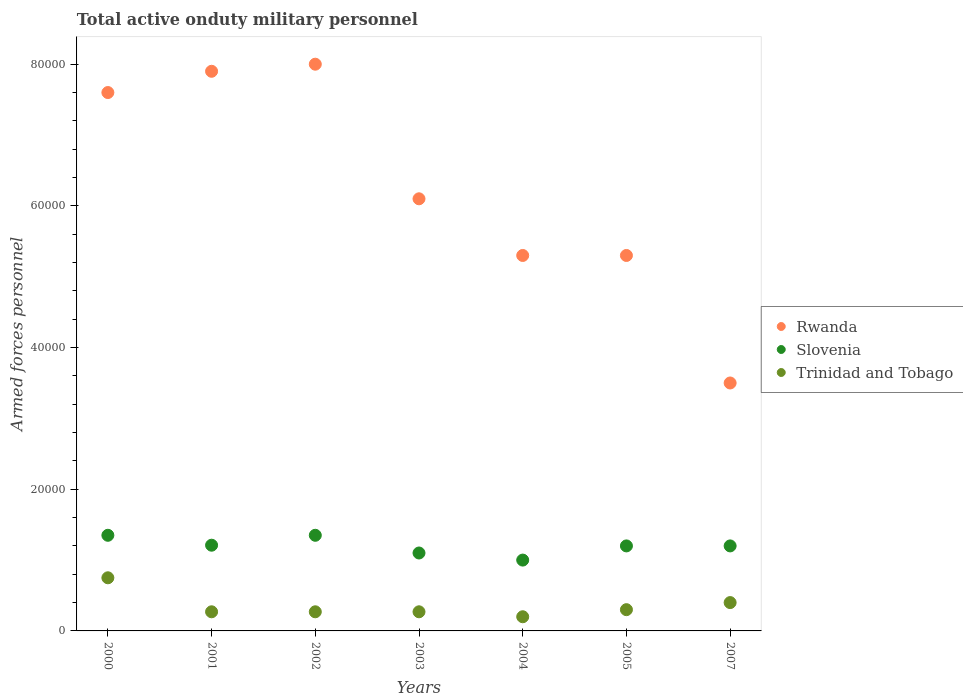How many different coloured dotlines are there?
Offer a very short reply. 3. What is the number of armed forces personnel in Trinidad and Tobago in 2003?
Offer a terse response. 2700. Across all years, what is the maximum number of armed forces personnel in Trinidad and Tobago?
Your answer should be compact. 7500. What is the total number of armed forces personnel in Trinidad and Tobago in the graph?
Make the answer very short. 2.46e+04. What is the difference between the number of armed forces personnel in Trinidad and Tobago in 2005 and that in 2007?
Your answer should be very brief. -1000. What is the difference between the number of armed forces personnel in Rwanda in 2002 and the number of armed forces personnel in Trinidad and Tobago in 2000?
Your answer should be compact. 7.25e+04. What is the average number of armed forces personnel in Trinidad and Tobago per year?
Provide a short and direct response. 3514.29. In the year 2004, what is the difference between the number of armed forces personnel in Slovenia and number of armed forces personnel in Rwanda?
Your answer should be compact. -4.30e+04. What is the ratio of the number of armed forces personnel in Trinidad and Tobago in 2004 to that in 2007?
Your answer should be compact. 0.5. Is the number of armed forces personnel in Slovenia in 2001 less than that in 2004?
Your answer should be compact. No. Is the difference between the number of armed forces personnel in Slovenia in 2002 and 2007 greater than the difference between the number of armed forces personnel in Rwanda in 2002 and 2007?
Give a very brief answer. No. What is the difference between the highest and the second highest number of armed forces personnel in Trinidad and Tobago?
Keep it short and to the point. 3500. What is the difference between the highest and the lowest number of armed forces personnel in Trinidad and Tobago?
Your response must be concise. 5500. Is the sum of the number of armed forces personnel in Trinidad and Tobago in 2003 and 2007 greater than the maximum number of armed forces personnel in Rwanda across all years?
Keep it short and to the point. No. Does the number of armed forces personnel in Trinidad and Tobago monotonically increase over the years?
Ensure brevity in your answer.  No. How many dotlines are there?
Keep it short and to the point. 3. How many years are there in the graph?
Your answer should be compact. 7. Are the values on the major ticks of Y-axis written in scientific E-notation?
Your answer should be very brief. No. Does the graph contain any zero values?
Offer a very short reply. No. What is the title of the graph?
Offer a very short reply. Total active onduty military personnel. What is the label or title of the X-axis?
Your answer should be compact. Years. What is the label or title of the Y-axis?
Ensure brevity in your answer.  Armed forces personnel. What is the Armed forces personnel of Rwanda in 2000?
Offer a terse response. 7.60e+04. What is the Armed forces personnel in Slovenia in 2000?
Your answer should be compact. 1.35e+04. What is the Armed forces personnel of Trinidad and Tobago in 2000?
Provide a short and direct response. 7500. What is the Armed forces personnel of Rwanda in 2001?
Keep it short and to the point. 7.90e+04. What is the Armed forces personnel in Slovenia in 2001?
Offer a terse response. 1.21e+04. What is the Armed forces personnel of Trinidad and Tobago in 2001?
Offer a terse response. 2700. What is the Armed forces personnel of Slovenia in 2002?
Give a very brief answer. 1.35e+04. What is the Armed forces personnel in Trinidad and Tobago in 2002?
Give a very brief answer. 2700. What is the Armed forces personnel in Rwanda in 2003?
Your answer should be very brief. 6.10e+04. What is the Armed forces personnel of Slovenia in 2003?
Provide a short and direct response. 1.10e+04. What is the Armed forces personnel in Trinidad and Tobago in 2003?
Your answer should be very brief. 2700. What is the Armed forces personnel of Rwanda in 2004?
Your answer should be very brief. 5.30e+04. What is the Armed forces personnel in Slovenia in 2004?
Offer a very short reply. 10000. What is the Armed forces personnel of Rwanda in 2005?
Give a very brief answer. 5.30e+04. What is the Armed forces personnel in Slovenia in 2005?
Offer a very short reply. 1.20e+04. What is the Armed forces personnel in Trinidad and Tobago in 2005?
Keep it short and to the point. 3000. What is the Armed forces personnel of Rwanda in 2007?
Offer a very short reply. 3.50e+04. What is the Armed forces personnel in Slovenia in 2007?
Ensure brevity in your answer.  1.20e+04. What is the Armed forces personnel in Trinidad and Tobago in 2007?
Ensure brevity in your answer.  4000. Across all years, what is the maximum Armed forces personnel of Slovenia?
Make the answer very short. 1.35e+04. Across all years, what is the maximum Armed forces personnel of Trinidad and Tobago?
Offer a terse response. 7500. Across all years, what is the minimum Armed forces personnel in Rwanda?
Provide a short and direct response. 3.50e+04. Across all years, what is the minimum Armed forces personnel of Trinidad and Tobago?
Your response must be concise. 2000. What is the total Armed forces personnel in Rwanda in the graph?
Provide a succinct answer. 4.37e+05. What is the total Armed forces personnel in Slovenia in the graph?
Provide a succinct answer. 8.41e+04. What is the total Armed forces personnel in Trinidad and Tobago in the graph?
Make the answer very short. 2.46e+04. What is the difference between the Armed forces personnel of Rwanda in 2000 and that in 2001?
Your answer should be very brief. -3000. What is the difference between the Armed forces personnel in Slovenia in 2000 and that in 2001?
Offer a very short reply. 1400. What is the difference between the Armed forces personnel in Trinidad and Tobago in 2000 and that in 2001?
Ensure brevity in your answer.  4800. What is the difference between the Armed forces personnel of Rwanda in 2000 and that in 2002?
Give a very brief answer. -4000. What is the difference between the Armed forces personnel of Trinidad and Tobago in 2000 and that in 2002?
Give a very brief answer. 4800. What is the difference between the Armed forces personnel of Rwanda in 2000 and that in 2003?
Offer a very short reply. 1.50e+04. What is the difference between the Armed forces personnel in Slovenia in 2000 and that in 2003?
Give a very brief answer. 2500. What is the difference between the Armed forces personnel in Trinidad and Tobago in 2000 and that in 2003?
Your response must be concise. 4800. What is the difference between the Armed forces personnel in Rwanda in 2000 and that in 2004?
Your response must be concise. 2.30e+04. What is the difference between the Armed forces personnel of Slovenia in 2000 and that in 2004?
Provide a succinct answer. 3500. What is the difference between the Armed forces personnel of Trinidad and Tobago in 2000 and that in 2004?
Keep it short and to the point. 5500. What is the difference between the Armed forces personnel of Rwanda in 2000 and that in 2005?
Your response must be concise. 2.30e+04. What is the difference between the Armed forces personnel of Slovenia in 2000 and that in 2005?
Ensure brevity in your answer.  1500. What is the difference between the Armed forces personnel in Trinidad and Tobago in 2000 and that in 2005?
Ensure brevity in your answer.  4500. What is the difference between the Armed forces personnel of Rwanda in 2000 and that in 2007?
Make the answer very short. 4.10e+04. What is the difference between the Armed forces personnel in Slovenia in 2000 and that in 2007?
Provide a succinct answer. 1500. What is the difference between the Armed forces personnel in Trinidad and Tobago in 2000 and that in 2007?
Make the answer very short. 3500. What is the difference between the Armed forces personnel of Rwanda in 2001 and that in 2002?
Offer a very short reply. -1000. What is the difference between the Armed forces personnel in Slovenia in 2001 and that in 2002?
Offer a terse response. -1400. What is the difference between the Armed forces personnel in Rwanda in 2001 and that in 2003?
Ensure brevity in your answer.  1.80e+04. What is the difference between the Armed forces personnel in Slovenia in 2001 and that in 2003?
Give a very brief answer. 1100. What is the difference between the Armed forces personnel of Rwanda in 2001 and that in 2004?
Offer a terse response. 2.60e+04. What is the difference between the Armed forces personnel in Slovenia in 2001 and that in 2004?
Ensure brevity in your answer.  2100. What is the difference between the Armed forces personnel of Trinidad and Tobago in 2001 and that in 2004?
Offer a very short reply. 700. What is the difference between the Armed forces personnel in Rwanda in 2001 and that in 2005?
Provide a short and direct response. 2.60e+04. What is the difference between the Armed forces personnel of Slovenia in 2001 and that in 2005?
Provide a succinct answer. 100. What is the difference between the Armed forces personnel in Trinidad and Tobago in 2001 and that in 2005?
Keep it short and to the point. -300. What is the difference between the Armed forces personnel of Rwanda in 2001 and that in 2007?
Offer a very short reply. 4.40e+04. What is the difference between the Armed forces personnel of Slovenia in 2001 and that in 2007?
Ensure brevity in your answer.  100. What is the difference between the Armed forces personnel of Trinidad and Tobago in 2001 and that in 2007?
Offer a very short reply. -1300. What is the difference between the Armed forces personnel of Rwanda in 2002 and that in 2003?
Keep it short and to the point. 1.90e+04. What is the difference between the Armed forces personnel of Slovenia in 2002 and that in 2003?
Your answer should be compact. 2500. What is the difference between the Armed forces personnel of Trinidad and Tobago in 2002 and that in 2003?
Give a very brief answer. 0. What is the difference between the Armed forces personnel of Rwanda in 2002 and that in 2004?
Offer a terse response. 2.70e+04. What is the difference between the Armed forces personnel in Slovenia in 2002 and that in 2004?
Give a very brief answer. 3500. What is the difference between the Armed forces personnel in Trinidad and Tobago in 2002 and that in 2004?
Make the answer very short. 700. What is the difference between the Armed forces personnel in Rwanda in 2002 and that in 2005?
Your answer should be compact. 2.70e+04. What is the difference between the Armed forces personnel of Slovenia in 2002 and that in 2005?
Provide a succinct answer. 1500. What is the difference between the Armed forces personnel of Trinidad and Tobago in 2002 and that in 2005?
Make the answer very short. -300. What is the difference between the Armed forces personnel in Rwanda in 2002 and that in 2007?
Your answer should be compact. 4.50e+04. What is the difference between the Armed forces personnel of Slovenia in 2002 and that in 2007?
Offer a very short reply. 1500. What is the difference between the Armed forces personnel in Trinidad and Tobago in 2002 and that in 2007?
Your answer should be very brief. -1300. What is the difference between the Armed forces personnel in Rwanda in 2003 and that in 2004?
Offer a terse response. 8000. What is the difference between the Armed forces personnel of Slovenia in 2003 and that in 2004?
Your answer should be very brief. 1000. What is the difference between the Armed forces personnel of Trinidad and Tobago in 2003 and that in 2004?
Give a very brief answer. 700. What is the difference between the Armed forces personnel in Rwanda in 2003 and that in 2005?
Ensure brevity in your answer.  8000. What is the difference between the Armed forces personnel in Slovenia in 2003 and that in 2005?
Your answer should be very brief. -1000. What is the difference between the Armed forces personnel in Trinidad and Tobago in 2003 and that in 2005?
Offer a very short reply. -300. What is the difference between the Armed forces personnel of Rwanda in 2003 and that in 2007?
Offer a very short reply. 2.60e+04. What is the difference between the Armed forces personnel of Slovenia in 2003 and that in 2007?
Your response must be concise. -1000. What is the difference between the Armed forces personnel of Trinidad and Tobago in 2003 and that in 2007?
Your response must be concise. -1300. What is the difference between the Armed forces personnel of Slovenia in 2004 and that in 2005?
Provide a succinct answer. -2000. What is the difference between the Armed forces personnel in Trinidad and Tobago in 2004 and that in 2005?
Your answer should be very brief. -1000. What is the difference between the Armed forces personnel of Rwanda in 2004 and that in 2007?
Give a very brief answer. 1.80e+04. What is the difference between the Armed forces personnel of Slovenia in 2004 and that in 2007?
Provide a short and direct response. -2000. What is the difference between the Armed forces personnel in Trinidad and Tobago in 2004 and that in 2007?
Your answer should be compact. -2000. What is the difference between the Armed forces personnel of Rwanda in 2005 and that in 2007?
Your answer should be compact. 1.80e+04. What is the difference between the Armed forces personnel in Slovenia in 2005 and that in 2007?
Your answer should be compact. 0. What is the difference between the Armed forces personnel of Trinidad and Tobago in 2005 and that in 2007?
Your response must be concise. -1000. What is the difference between the Armed forces personnel of Rwanda in 2000 and the Armed forces personnel of Slovenia in 2001?
Offer a very short reply. 6.39e+04. What is the difference between the Armed forces personnel in Rwanda in 2000 and the Armed forces personnel in Trinidad and Tobago in 2001?
Your response must be concise. 7.33e+04. What is the difference between the Armed forces personnel of Slovenia in 2000 and the Armed forces personnel of Trinidad and Tobago in 2001?
Your answer should be very brief. 1.08e+04. What is the difference between the Armed forces personnel in Rwanda in 2000 and the Armed forces personnel in Slovenia in 2002?
Your answer should be very brief. 6.25e+04. What is the difference between the Armed forces personnel of Rwanda in 2000 and the Armed forces personnel of Trinidad and Tobago in 2002?
Keep it short and to the point. 7.33e+04. What is the difference between the Armed forces personnel of Slovenia in 2000 and the Armed forces personnel of Trinidad and Tobago in 2002?
Provide a short and direct response. 1.08e+04. What is the difference between the Armed forces personnel in Rwanda in 2000 and the Armed forces personnel in Slovenia in 2003?
Keep it short and to the point. 6.50e+04. What is the difference between the Armed forces personnel in Rwanda in 2000 and the Armed forces personnel in Trinidad and Tobago in 2003?
Your answer should be very brief. 7.33e+04. What is the difference between the Armed forces personnel of Slovenia in 2000 and the Armed forces personnel of Trinidad and Tobago in 2003?
Offer a very short reply. 1.08e+04. What is the difference between the Armed forces personnel in Rwanda in 2000 and the Armed forces personnel in Slovenia in 2004?
Provide a short and direct response. 6.60e+04. What is the difference between the Armed forces personnel in Rwanda in 2000 and the Armed forces personnel in Trinidad and Tobago in 2004?
Give a very brief answer. 7.40e+04. What is the difference between the Armed forces personnel in Slovenia in 2000 and the Armed forces personnel in Trinidad and Tobago in 2004?
Offer a very short reply. 1.15e+04. What is the difference between the Armed forces personnel of Rwanda in 2000 and the Armed forces personnel of Slovenia in 2005?
Give a very brief answer. 6.40e+04. What is the difference between the Armed forces personnel in Rwanda in 2000 and the Armed forces personnel in Trinidad and Tobago in 2005?
Offer a very short reply. 7.30e+04. What is the difference between the Armed forces personnel in Slovenia in 2000 and the Armed forces personnel in Trinidad and Tobago in 2005?
Your answer should be very brief. 1.05e+04. What is the difference between the Armed forces personnel in Rwanda in 2000 and the Armed forces personnel in Slovenia in 2007?
Make the answer very short. 6.40e+04. What is the difference between the Armed forces personnel in Rwanda in 2000 and the Armed forces personnel in Trinidad and Tobago in 2007?
Make the answer very short. 7.20e+04. What is the difference between the Armed forces personnel in Slovenia in 2000 and the Armed forces personnel in Trinidad and Tobago in 2007?
Give a very brief answer. 9500. What is the difference between the Armed forces personnel of Rwanda in 2001 and the Armed forces personnel of Slovenia in 2002?
Provide a succinct answer. 6.55e+04. What is the difference between the Armed forces personnel in Rwanda in 2001 and the Armed forces personnel in Trinidad and Tobago in 2002?
Make the answer very short. 7.63e+04. What is the difference between the Armed forces personnel in Slovenia in 2001 and the Armed forces personnel in Trinidad and Tobago in 2002?
Offer a very short reply. 9400. What is the difference between the Armed forces personnel of Rwanda in 2001 and the Armed forces personnel of Slovenia in 2003?
Offer a very short reply. 6.80e+04. What is the difference between the Armed forces personnel of Rwanda in 2001 and the Armed forces personnel of Trinidad and Tobago in 2003?
Offer a very short reply. 7.63e+04. What is the difference between the Armed forces personnel in Slovenia in 2001 and the Armed forces personnel in Trinidad and Tobago in 2003?
Offer a very short reply. 9400. What is the difference between the Armed forces personnel of Rwanda in 2001 and the Armed forces personnel of Slovenia in 2004?
Give a very brief answer. 6.90e+04. What is the difference between the Armed forces personnel in Rwanda in 2001 and the Armed forces personnel in Trinidad and Tobago in 2004?
Keep it short and to the point. 7.70e+04. What is the difference between the Armed forces personnel of Slovenia in 2001 and the Armed forces personnel of Trinidad and Tobago in 2004?
Ensure brevity in your answer.  1.01e+04. What is the difference between the Armed forces personnel of Rwanda in 2001 and the Armed forces personnel of Slovenia in 2005?
Keep it short and to the point. 6.70e+04. What is the difference between the Armed forces personnel of Rwanda in 2001 and the Armed forces personnel of Trinidad and Tobago in 2005?
Ensure brevity in your answer.  7.60e+04. What is the difference between the Armed forces personnel of Slovenia in 2001 and the Armed forces personnel of Trinidad and Tobago in 2005?
Make the answer very short. 9100. What is the difference between the Armed forces personnel in Rwanda in 2001 and the Armed forces personnel in Slovenia in 2007?
Give a very brief answer. 6.70e+04. What is the difference between the Armed forces personnel in Rwanda in 2001 and the Armed forces personnel in Trinidad and Tobago in 2007?
Offer a terse response. 7.50e+04. What is the difference between the Armed forces personnel of Slovenia in 2001 and the Armed forces personnel of Trinidad and Tobago in 2007?
Give a very brief answer. 8100. What is the difference between the Armed forces personnel in Rwanda in 2002 and the Armed forces personnel in Slovenia in 2003?
Provide a succinct answer. 6.90e+04. What is the difference between the Armed forces personnel in Rwanda in 2002 and the Armed forces personnel in Trinidad and Tobago in 2003?
Make the answer very short. 7.73e+04. What is the difference between the Armed forces personnel of Slovenia in 2002 and the Armed forces personnel of Trinidad and Tobago in 2003?
Keep it short and to the point. 1.08e+04. What is the difference between the Armed forces personnel in Rwanda in 2002 and the Armed forces personnel in Trinidad and Tobago in 2004?
Provide a short and direct response. 7.80e+04. What is the difference between the Armed forces personnel in Slovenia in 2002 and the Armed forces personnel in Trinidad and Tobago in 2004?
Provide a short and direct response. 1.15e+04. What is the difference between the Armed forces personnel of Rwanda in 2002 and the Armed forces personnel of Slovenia in 2005?
Provide a succinct answer. 6.80e+04. What is the difference between the Armed forces personnel of Rwanda in 2002 and the Armed forces personnel of Trinidad and Tobago in 2005?
Provide a short and direct response. 7.70e+04. What is the difference between the Armed forces personnel of Slovenia in 2002 and the Armed forces personnel of Trinidad and Tobago in 2005?
Give a very brief answer. 1.05e+04. What is the difference between the Armed forces personnel of Rwanda in 2002 and the Armed forces personnel of Slovenia in 2007?
Provide a short and direct response. 6.80e+04. What is the difference between the Armed forces personnel in Rwanda in 2002 and the Armed forces personnel in Trinidad and Tobago in 2007?
Ensure brevity in your answer.  7.60e+04. What is the difference between the Armed forces personnel of Slovenia in 2002 and the Armed forces personnel of Trinidad and Tobago in 2007?
Offer a very short reply. 9500. What is the difference between the Armed forces personnel in Rwanda in 2003 and the Armed forces personnel in Slovenia in 2004?
Your answer should be compact. 5.10e+04. What is the difference between the Armed forces personnel in Rwanda in 2003 and the Armed forces personnel in Trinidad and Tobago in 2004?
Give a very brief answer. 5.90e+04. What is the difference between the Armed forces personnel of Slovenia in 2003 and the Armed forces personnel of Trinidad and Tobago in 2004?
Offer a very short reply. 9000. What is the difference between the Armed forces personnel in Rwanda in 2003 and the Armed forces personnel in Slovenia in 2005?
Offer a terse response. 4.90e+04. What is the difference between the Armed forces personnel of Rwanda in 2003 and the Armed forces personnel of Trinidad and Tobago in 2005?
Offer a very short reply. 5.80e+04. What is the difference between the Armed forces personnel of Slovenia in 2003 and the Armed forces personnel of Trinidad and Tobago in 2005?
Give a very brief answer. 8000. What is the difference between the Armed forces personnel in Rwanda in 2003 and the Armed forces personnel in Slovenia in 2007?
Your answer should be very brief. 4.90e+04. What is the difference between the Armed forces personnel of Rwanda in 2003 and the Armed forces personnel of Trinidad and Tobago in 2007?
Give a very brief answer. 5.70e+04. What is the difference between the Armed forces personnel of Slovenia in 2003 and the Armed forces personnel of Trinidad and Tobago in 2007?
Offer a very short reply. 7000. What is the difference between the Armed forces personnel in Rwanda in 2004 and the Armed forces personnel in Slovenia in 2005?
Ensure brevity in your answer.  4.10e+04. What is the difference between the Armed forces personnel of Rwanda in 2004 and the Armed forces personnel of Trinidad and Tobago in 2005?
Make the answer very short. 5.00e+04. What is the difference between the Armed forces personnel in Slovenia in 2004 and the Armed forces personnel in Trinidad and Tobago in 2005?
Your answer should be compact. 7000. What is the difference between the Armed forces personnel of Rwanda in 2004 and the Armed forces personnel of Slovenia in 2007?
Ensure brevity in your answer.  4.10e+04. What is the difference between the Armed forces personnel in Rwanda in 2004 and the Armed forces personnel in Trinidad and Tobago in 2007?
Keep it short and to the point. 4.90e+04. What is the difference between the Armed forces personnel of Slovenia in 2004 and the Armed forces personnel of Trinidad and Tobago in 2007?
Your answer should be very brief. 6000. What is the difference between the Armed forces personnel in Rwanda in 2005 and the Armed forces personnel in Slovenia in 2007?
Offer a terse response. 4.10e+04. What is the difference between the Armed forces personnel of Rwanda in 2005 and the Armed forces personnel of Trinidad and Tobago in 2007?
Provide a short and direct response. 4.90e+04. What is the difference between the Armed forces personnel of Slovenia in 2005 and the Armed forces personnel of Trinidad and Tobago in 2007?
Make the answer very short. 8000. What is the average Armed forces personnel in Rwanda per year?
Your answer should be compact. 6.24e+04. What is the average Armed forces personnel of Slovenia per year?
Offer a very short reply. 1.20e+04. What is the average Armed forces personnel of Trinidad and Tobago per year?
Give a very brief answer. 3514.29. In the year 2000, what is the difference between the Armed forces personnel in Rwanda and Armed forces personnel in Slovenia?
Offer a very short reply. 6.25e+04. In the year 2000, what is the difference between the Armed forces personnel of Rwanda and Armed forces personnel of Trinidad and Tobago?
Make the answer very short. 6.85e+04. In the year 2000, what is the difference between the Armed forces personnel of Slovenia and Armed forces personnel of Trinidad and Tobago?
Your response must be concise. 6000. In the year 2001, what is the difference between the Armed forces personnel of Rwanda and Armed forces personnel of Slovenia?
Keep it short and to the point. 6.69e+04. In the year 2001, what is the difference between the Armed forces personnel in Rwanda and Armed forces personnel in Trinidad and Tobago?
Make the answer very short. 7.63e+04. In the year 2001, what is the difference between the Armed forces personnel in Slovenia and Armed forces personnel in Trinidad and Tobago?
Offer a very short reply. 9400. In the year 2002, what is the difference between the Armed forces personnel of Rwanda and Armed forces personnel of Slovenia?
Provide a short and direct response. 6.65e+04. In the year 2002, what is the difference between the Armed forces personnel of Rwanda and Armed forces personnel of Trinidad and Tobago?
Make the answer very short. 7.73e+04. In the year 2002, what is the difference between the Armed forces personnel in Slovenia and Armed forces personnel in Trinidad and Tobago?
Give a very brief answer. 1.08e+04. In the year 2003, what is the difference between the Armed forces personnel of Rwanda and Armed forces personnel of Trinidad and Tobago?
Provide a short and direct response. 5.83e+04. In the year 2003, what is the difference between the Armed forces personnel of Slovenia and Armed forces personnel of Trinidad and Tobago?
Your answer should be very brief. 8300. In the year 2004, what is the difference between the Armed forces personnel in Rwanda and Armed forces personnel in Slovenia?
Your response must be concise. 4.30e+04. In the year 2004, what is the difference between the Armed forces personnel of Rwanda and Armed forces personnel of Trinidad and Tobago?
Make the answer very short. 5.10e+04. In the year 2004, what is the difference between the Armed forces personnel in Slovenia and Armed forces personnel in Trinidad and Tobago?
Keep it short and to the point. 8000. In the year 2005, what is the difference between the Armed forces personnel of Rwanda and Armed forces personnel of Slovenia?
Offer a very short reply. 4.10e+04. In the year 2005, what is the difference between the Armed forces personnel in Slovenia and Armed forces personnel in Trinidad and Tobago?
Your answer should be very brief. 9000. In the year 2007, what is the difference between the Armed forces personnel of Rwanda and Armed forces personnel of Slovenia?
Your answer should be very brief. 2.30e+04. In the year 2007, what is the difference between the Armed forces personnel in Rwanda and Armed forces personnel in Trinidad and Tobago?
Your response must be concise. 3.10e+04. In the year 2007, what is the difference between the Armed forces personnel of Slovenia and Armed forces personnel of Trinidad and Tobago?
Keep it short and to the point. 8000. What is the ratio of the Armed forces personnel of Rwanda in 2000 to that in 2001?
Your answer should be compact. 0.96. What is the ratio of the Armed forces personnel in Slovenia in 2000 to that in 2001?
Keep it short and to the point. 1.12. What is the ratio of the Armed forces personnel of Trinidad and Tobago in 2000 to that in 2001?
Ensure brevity in your answer.  2.78. What is the ratio of the Armed forces personnel in Rwanda in 2000 to that in 2002?
Your answer should be compact. 0.95. What is the ratio of the Armed forces personnel of Slovenia in 2000 to that in 2002?
Provide a succinct answer. 1. What is the ratio of the Armed forces personnel of Trinidad and Tobago in 2000 to that in 2002?
Offer a terse response. 2.78. What is the ratio of the Armed forces personnel in Rwanda in 2000 to that in 2003?
Your answer should be very brief. 1.25. What is the ratio of the Armed forces personnel in Slovenia in 2000 to that in 2003?
Provide a short and direct response. 1.23. What is the ratio of the Armed forces personnel in Trinidad and Tobago in 2000 to that in 2003?
Keep it short and to the point. 2.78. What is the ratio of the Armed forces personnel of Rwanda in 2000 to that in 2004?
Your response must be concise. 1.43. What is the ratio of the Armed forces personnel of Slovenia in 2000 to that in 2004?
Provide a succinct answer. 1.35. What is the ratio of the Armed forces personnel of Trinidad and Tobago in 2000 to that in 2004?
Offer a terse response. 3.75. What is the ratio of the Armed forces personnel of Rwanda in 2000 to that in 2005?
Offer a terse response. 1.43. What is the ratio of the Armed forces personnel of Rwanda in 2000 to that in 2007?
Give a very brief answer. 2.17. What is the ratio of the Armed forces personnel in Slovenia in 2000 to that in 2007?
Provide a short and direct response. 1.12. What is the ratio of the Armed forces personnel of Trinidad and Tobago in 2000 to that in 2007?
Your answer should be compact. 1.88. What is the ratio of the Armed forces personnel in Rwanda in 2001 to that in 2002?
Your answer should be very brief. 0.99. What is the ratio of the Armed forces personnel of Slovenia in 2001 to that in 2002?
Keep it short and to the point. 0.9. What is the ratio of the Armed forces personnel of Rwanda in 2001 to that in 2003?
Give a very brief answer. 1.3. What is the ratio of the Armed forces personnel in Slovenia in 2001 to that in 2003?
Ensure brevity in your answer.  1.1. What is the ratio of the Armed forces personnel in Rwanda in 2001 to that in 2004?
Provide a succinct answer. 1.49. What is the ratio of the Armed forces personnel in Slovenia in 2001 to that in 2004?
Your answer should be compact. 1.21. What is the ratio of the Armed forces personnel of Trinidad and Tobago in 2001 to that in 2004?
Offer a very short reply. 1.35. What is the ratio of the Armed forces personnel of Rwanda in 2001 to that in 2005?
Offer a very short reply. 1.49. What is the ratio of the Armed forces personnel in Slovenia in 2001 to that in 2005?
Your answer should be compact. 1.01. What is the ratio of the Armed forces personnel of Rwanda in 2001 to that in 2007?
Provide a succinct answer. 2.26. What is the ratio of the Armed forces personnel of Slovenia in 2001 to that in 2007?
Give a very brief answer. 1.01. What is the ratio of the Armed forces personnel in Trinidad and Tobago in 2001 to that in 2007?
Provide a succinct answer. 0.68. What is the ratio of the Armed forces personnel in Rwanda in 2002 to that in 2003?
Your answer should be compact. 1.31. What is the ratio of the Armed forces personnel in Slovenia in 2002 to that in 2003?
Your response must be concise. 1.23. What is the ratio of the Armed forces personnel of Trinidad and Tobago in 2002 to that in 2003?
Your answer should be compact. 1. What is the ratio of the Armed forces personnel in Rwanda in 2002 to that in 2004?
Your response must be concise. 1.51. What is the ratio of the Armed forces personnel in Slovenia in 2002 to that in 2004?
Your answer should be compact. 1.35. What is the ratio of the Armed forces personnel in Trinidad and Tobago in 2002 to that in 2004?
Provide a succinct answer. 1.35. What is the ratio of the Armed forces personnel of Rwanda in 2002 to that in 2005?
Your response must be concise. 1.51. What is the ratio of the Armed forces personnel in Trinidad and Tobago in 2002 to that in 2005?
Your answer should be very brief. 0.9. What is the ratio of the Armed forces personnel of Rwanda in 2002 to that in 2007?
Provide a succinct answer. 2.29. What is the ratio of the Armed forces personnel of Slovenia in 2002 to that in 2007?
Ensure brevity in your answer.  1.12. What is the ratio of the Armed forces personnel of Trinidad and Tobago in 2002 to that in 2007?
Offer a terse response. 0.68. What is the ratio of the Armed forces personnel in Rwanda in 2003 to that in 2004?
Your response must be concise. 1.15. What is the ratio of the Armed forces personnel in Slovenia in 2003 to that in 2004?
Keep it short and to the point. 1.1. What is the ratio of the Armed forces personnel of Trinidad and Tobago in 2003 to that in 2004?
Your answer should be very brief. 1.35. What is the ratio of the Armed forces personnel in Rwanda in 2003 to that in 2005?
Offer a very short reply. 1.15. What is the ratio of the Armed forces personnel of Trinidad and Tobago in 2003 to that in 2005?
Ensure brevity in your answer.  0.9. What is the ratio of the Armed forces personnel in Rwanda in 2003 to that in 2007?
Keep it short and to the point. 1.74. What is the ratio of the Armed forces personnel in Trinidad and Tobago in 2003 to that in 2007?
Your response must be concise. 0.68. What is the ratio of the Armed forces personnel in Rwanda in 2004 to that in 2007?
Your response must be concise. 1.51. What is the ratio of the Armed forces personnel in Slovenia in 2004 to that in 2007?
Provide a succinct answer. 0.83. What is the ratio of the Armed forces personnel in Rwanda in 2005 to that in 2007?
Provide a succinct answer. 1.51. What is the ratio of the Armed forces personnel of Slovenia in 2005 to that in 2007?
Keep it short and to the point. 1. What is the difference between the highest and the second highest Armed forces personnel in Rwanda?
Make the answer very short. 1000. What is the difference between the highest and the second highest Armed forces personnel of Slovenia?
Make the answer very short. 0. What is the difference between the highest and the second highest Armed forces personnel in Trinidad and Tobago?
Ensure brevity in your answer.  3500. What is the difference between the highest and the lowest Armed forces personnel in Rwanda?
Offer a very short reply. 4.50e+04. What is the difference between the highest and the lowest Armed forces personnel in Slovenia?
Ensure brevity in your answer.  3500. What is the difference between the highest and the lowest Armed forces personnel of Trinidad and Tobago?
Your answer should be compact. 5500. 